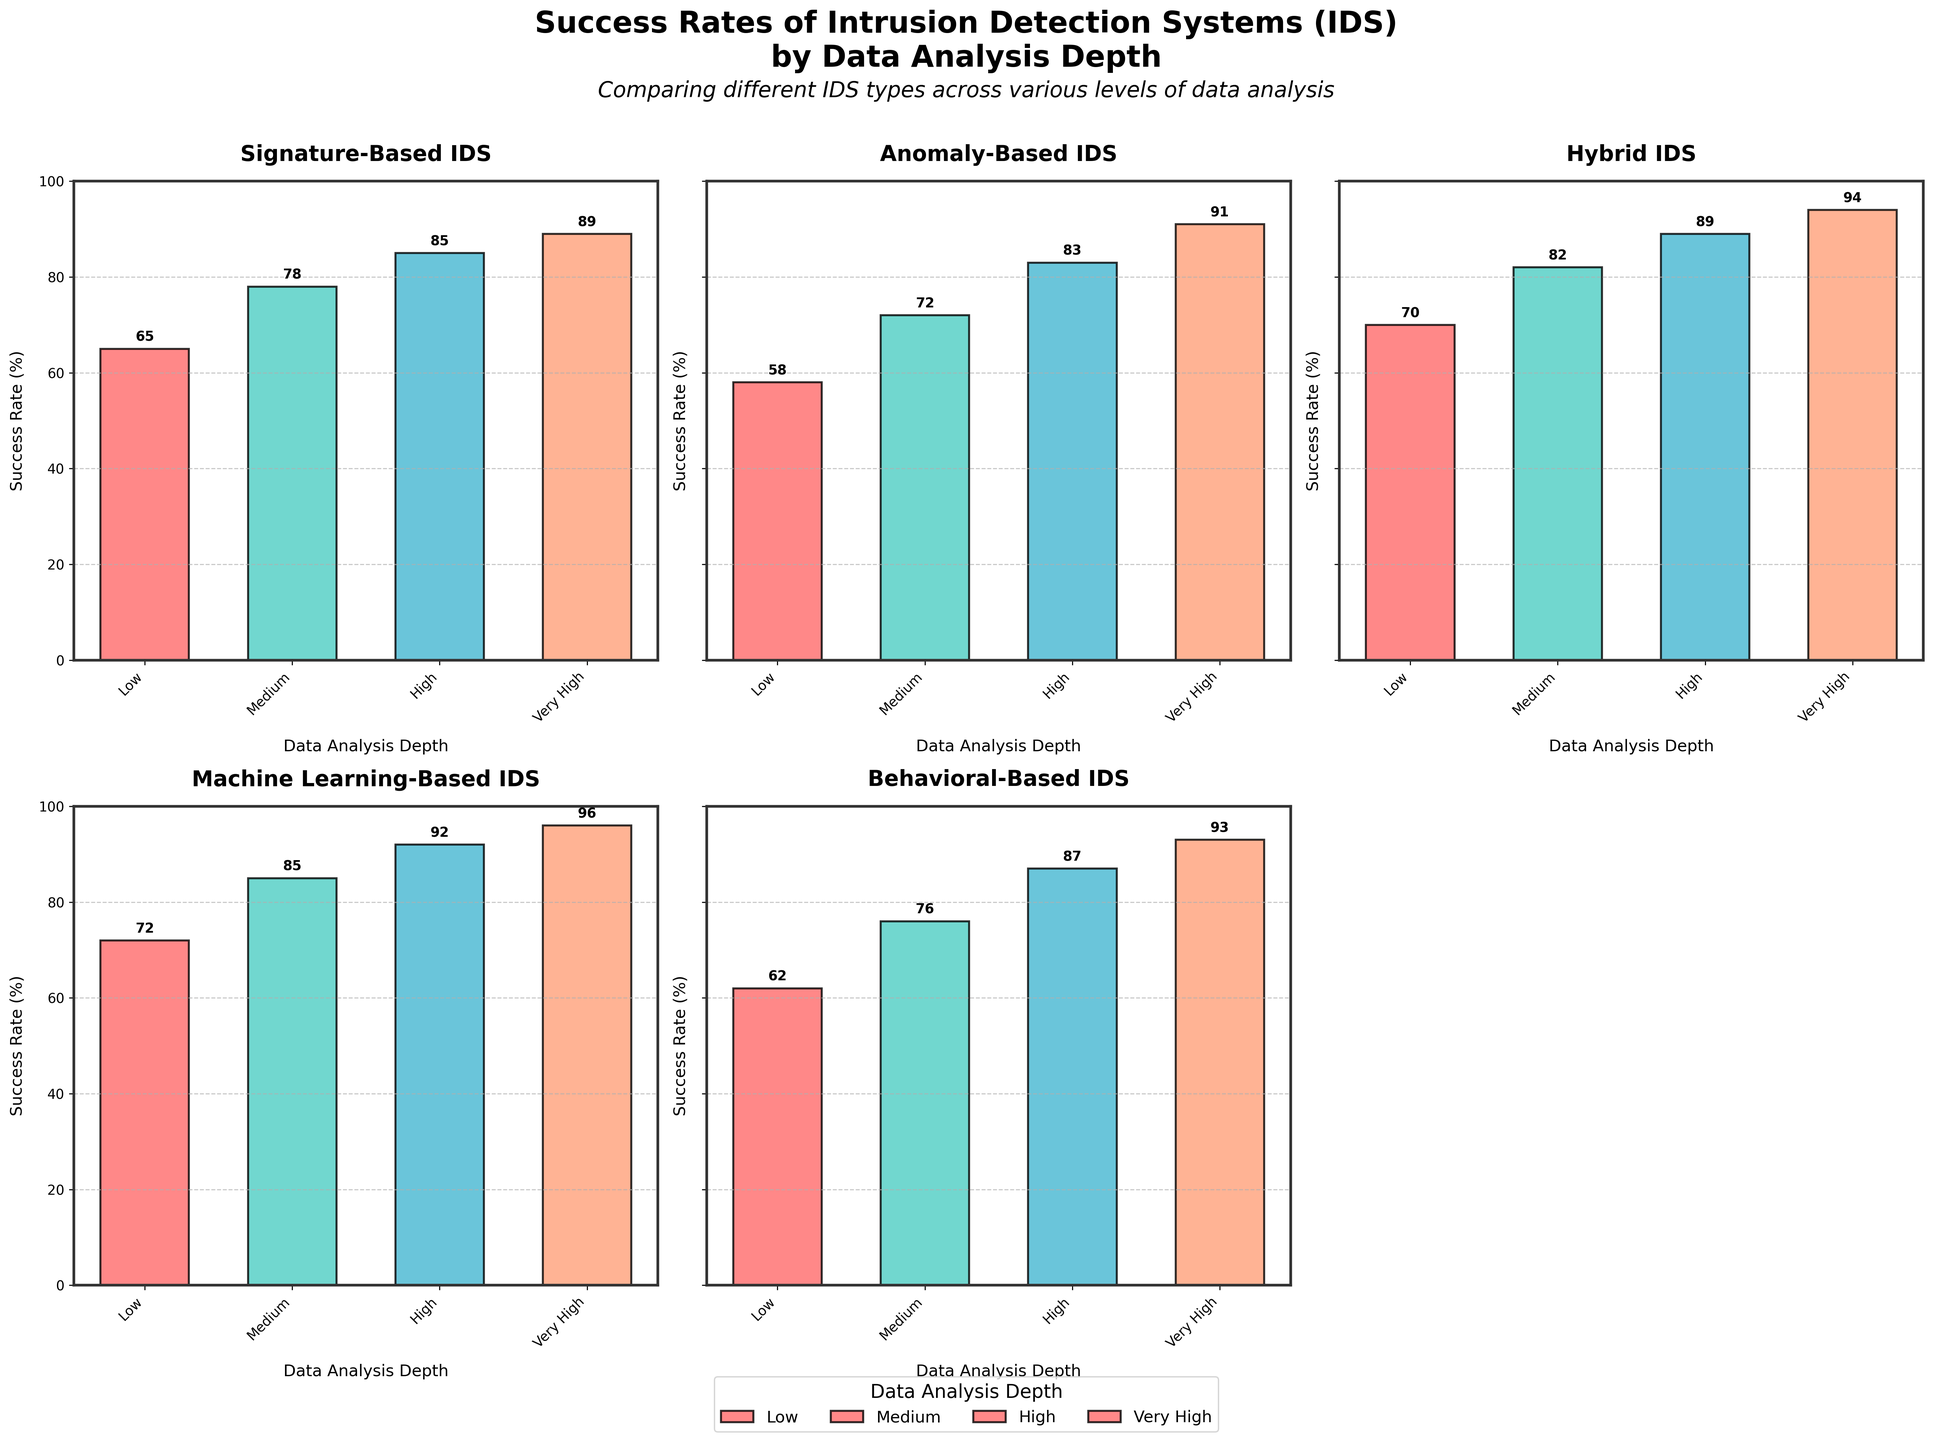What's the success rate of the Behavioral-Based IDS at very high data analysis depth? Looking at the bar labeled "Very High" under the "Behavioral-Based" IDS, we can see the success rate value.
Answer: 93 Which IDS type has the highest success rate at low data analysis depth? Compare the bars labeled "Low" for all IDS types to find the highest one. The "Machine Learning-Based" IDS has the tallest bar.
Answer: Machine Learning-Based How much higher is the success rate of the Anomaly-Based IDS at very high data analysis depth compared to the low data analysis depth? Subtract the success rate at "Low" depth from the rate at "Very High" depth for Anomaly-Based IDS. The values are 91 and 58, respectively.
Answer: 33 What is the average success rate of the Signature-Based IDS across all data analysis depths? Add the success rates for Signature-Based IDS (65, 78, 85, 89) and divide by 4: (65 + 78 + 85 + 89) / 4 = 79.25.
Answer: 79.25 Does the Statistical-Based IDS have a higher success rate than the Anomaly-Based IDS at high data analysis depth? Compare the "High" success rates of Statistical-Based IDS (84) and Anomaly-Based IDS (83).
Answer: Yes How does the Machine Learning-Based IDS' success rate at medium data analysis depth compare to the Signature-Based IDS' at high data analysis depth? Compare the success rates of Machine Learning-Based IDS at "Medium" (85) and Signature-Based IDS at "High" (85).
Answer: Equal Which IDS type shows the most improvement from low to very high data analysis depth? Calculate the improvement for each IDS type from "Low" to "Very High" depth and compare. Machine Learning-Based IDS improves from 72 to 96, a difference of 24, which is the largest.
Answer: Machine Learning-Based By how much does the success rate of the Hybrid IDS exceed that of the Signature-Based IDS at medium data analysis depth? Subtract the success rate of Signature-Based IDS at "Medium" (78) from that of Hybrid IDS at "Medium" (82).
Answer: 4 What color represents the bars for the very high data analysis depth? Observe the bar colors and identify the one used consistently for "Very High" across all subplots.
Answer: Blue What is the difference in success rates between the highest and lowest performing IDS at high data analysis depth? Identify the highest success rate at high depth (Machine Learning-Based at 92) and the lowest (Anomaly-Based at 83), then find the difference: 92 - 83 = 9.
Answer: 9 